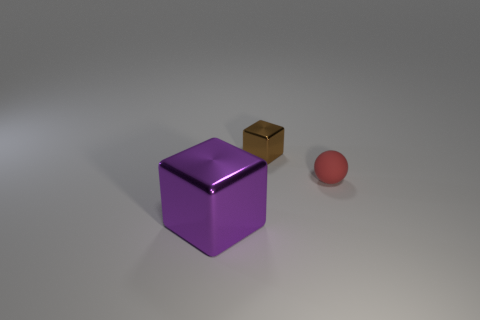Add 2 rubber balls. How many objects exist? 5 Subtract all brown cubes. How many cubes are left? 1 Subtract 2 cubes. How many cubes are left? 0 Subtract all blocks. How many objects are left? 1 Subtract 1 red balls. How many objects are left? 2 Subtract all brown spheres. Subtract all gray cylinders. How many spheres are left? 1 Subtract all green blocks. How many gray balls are left? 0 Subtract all cubes. Subtract all cyan rubber balls. How many objects are left? 1 Add 1 large purple objects. How many large purple objects are left? 2 Add 2 green rubber cylinders. How many green rubber cylinders exist? 2 